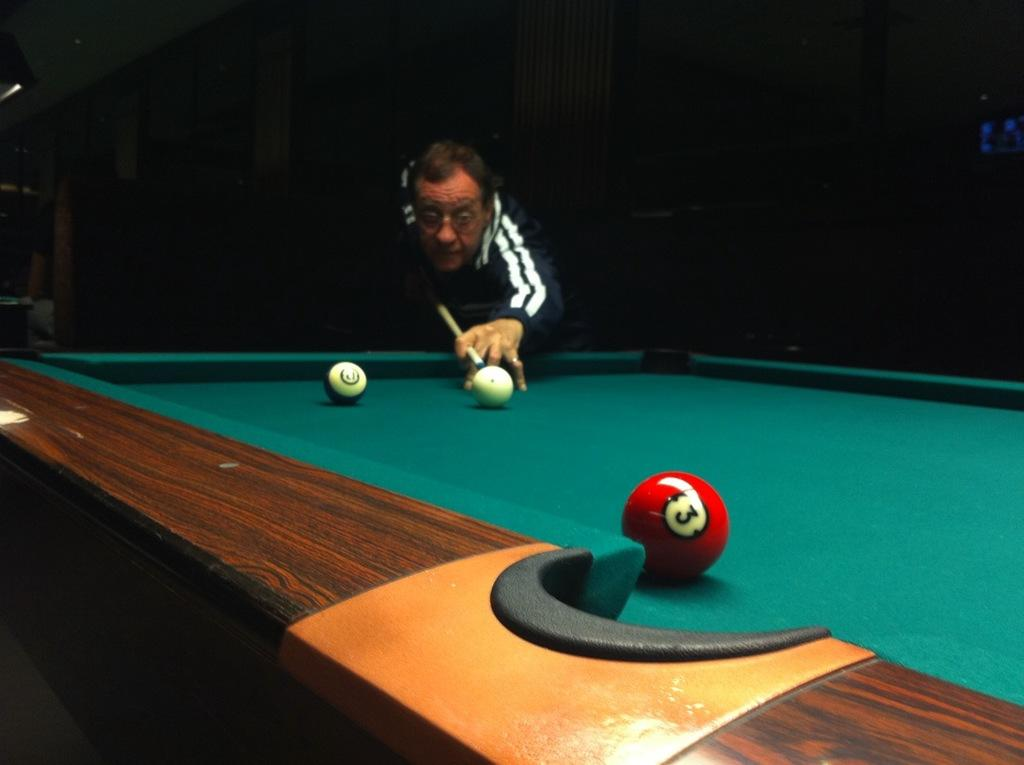What is the man in the image doing? The man is playing a pool game. What is the man holding in the image? The man is holding a stick. What is the color of the table where the game is being played? The table is green. What can be seen in the background of the image? There is a wall visible in the background, and there are people present as well. What type of nut can be heard cracking in the image? There is no nut present in the image, nor is there any sound of a nut cracking. 